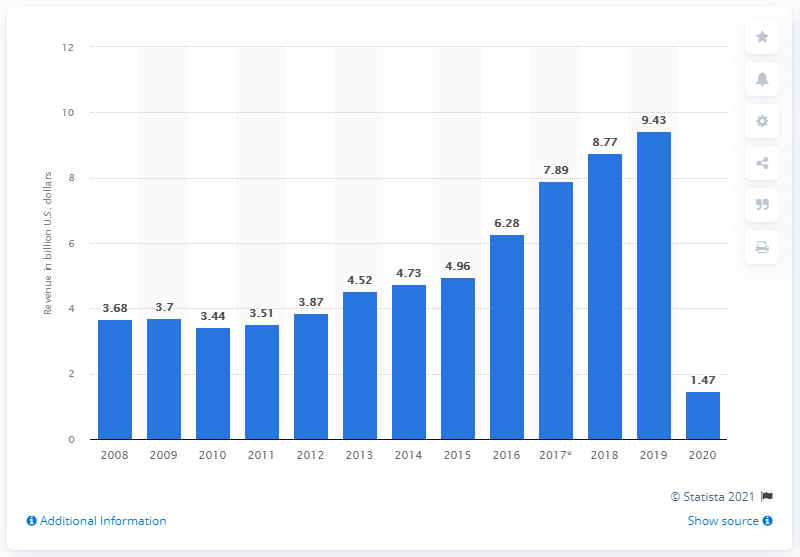Give some essential details in this illustration. Live Nation's revenue in 2020 was approximately 1.47 billion U.S. dollars. Live Nation's revenue in the previous year was 9.43. 